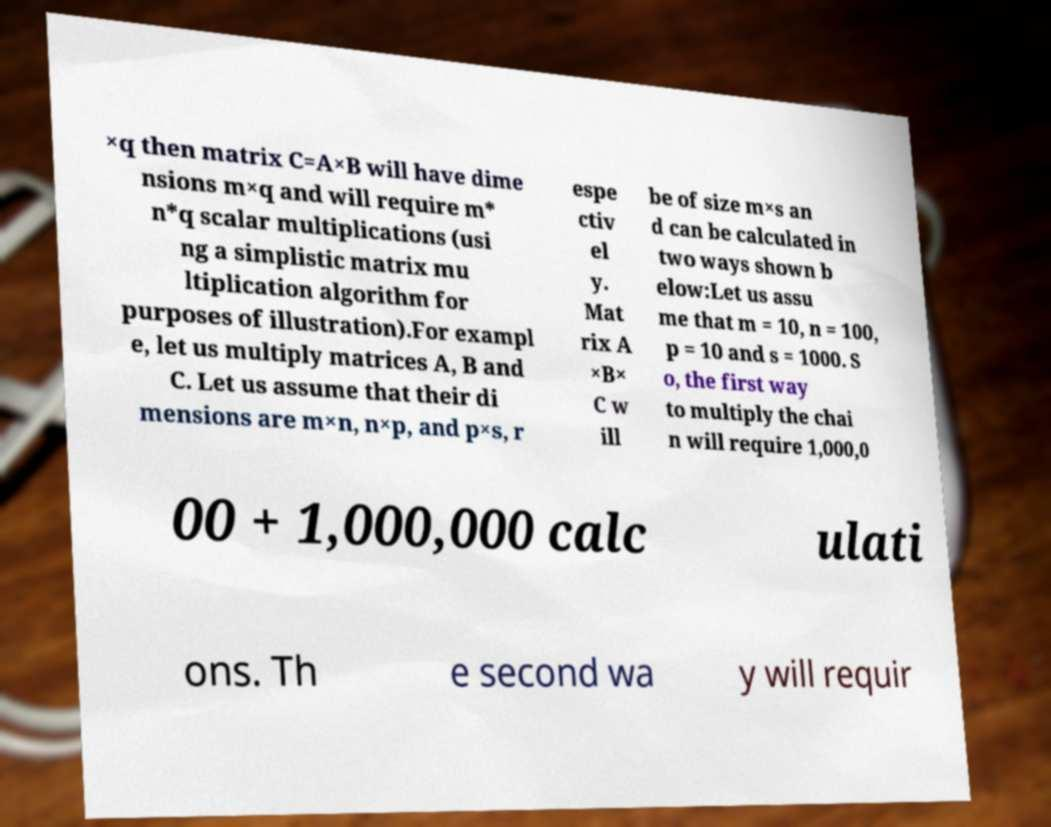Can you accurately transcribe the text from the provided image for me? ×q then matrix C=A×B will have dime nsions m×q and will require m* n*q scalar multiplications (usi ng a simplistic matrix mu ltiplication algorithm for purposes of illustration).For exampl e, let us multiply matrices A, B and C. Let us assume that their di mensions are m×n, n×p, and p×s, r espe ctiv el y. Mat rix A ×B× C w ill be of size m×s an d can be calculated in two ways shown b elow:Let us assu me that m = 10, n = 100, p = 10 and s = 1000. S o, the first way to multiply the chai n will require 1,000,0 00 + 1,000,000 calc ulati ons. Th e second wa y will requir 